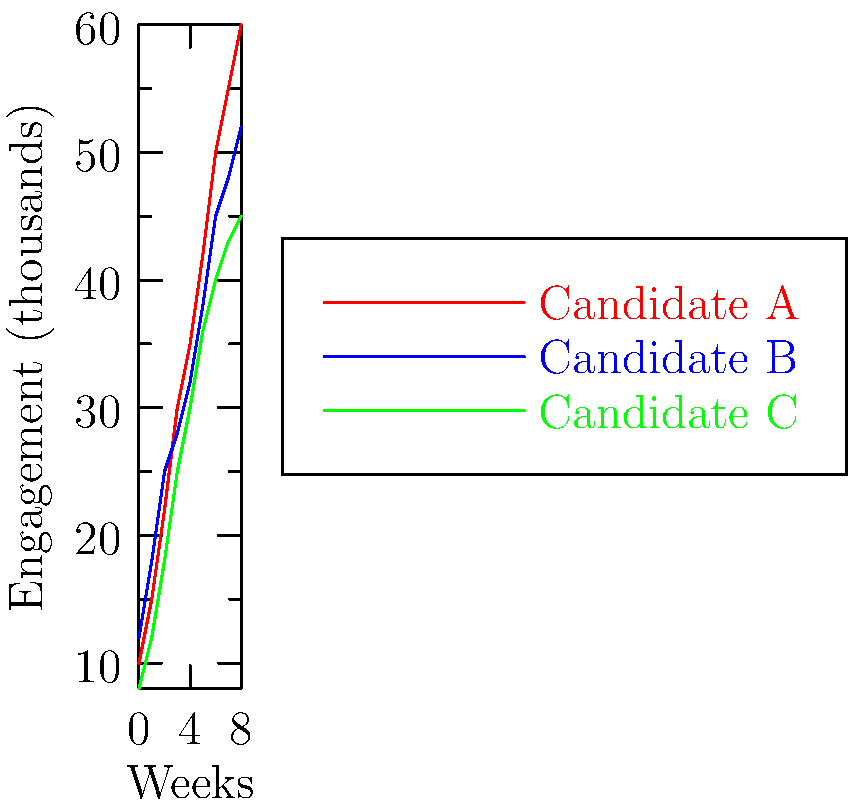Based on the line graph showing social media engagement for three political candidates over an 8-week period, which candidate demonstrated the most consistent growth rate in engagement throughout the campaign? To determine which candidate had the most consistent growth rate, we need to analyze the slope of each line:

1. Candidate A (red line):
   - Starts at 10,000 and ends at 60,000
   - Growth is steeper in the beginning, then slightly levels off
   - Not entirely consistent, but relatively steady

2. Candidate B (blue line):
   - Starts at 12,000 and ends at 52,000
   - Growth rate varies, with some periods of faster growth and others slower
   - Least consistent of the three

3. Candidate C (green line):
   - Starts at 8,000 and ends at 45,000
   - Line is almost straight, indicating a very consistent growth rate
   - Slope remains nearly constant throughout the 8-week period

Comparing these three, Candidate C shows the most consistent growth rate. The green line maintains an almost constant slope from start to finish, indicating a steady increase in engagement week over week.

This consistency in growth rate is particularly important in political campaigns, as it suggests a strategy that continually attracts new followers or increases engagement at a predictable rate, rather than relying on sporadic boosts or suffering from unexpected dips.
Answer: Candidate C 